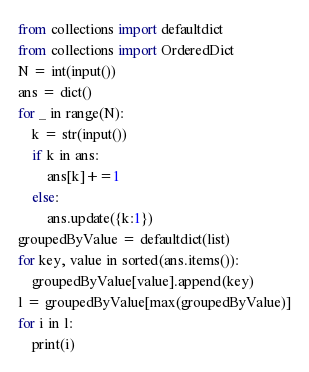Convert code to text. <code><loc_0><loc_0><loc_500><loc_500><_Python_>from collections import defaultdict
from collections import OrderedDict
N = int(input())
ans = dict()
for _ in range(N):
    k = str(input())
    if k in ans:
        ans[k]+=1
    else:
        ans.update({k:1})
groupedByValue = defaultdict(list)
for key, value in sorted(ans.items()):
    groupedByValue[value].append(key)
l = groupedByValue[max(groupedByValue)]
for i in l:
    print(i)</code> 